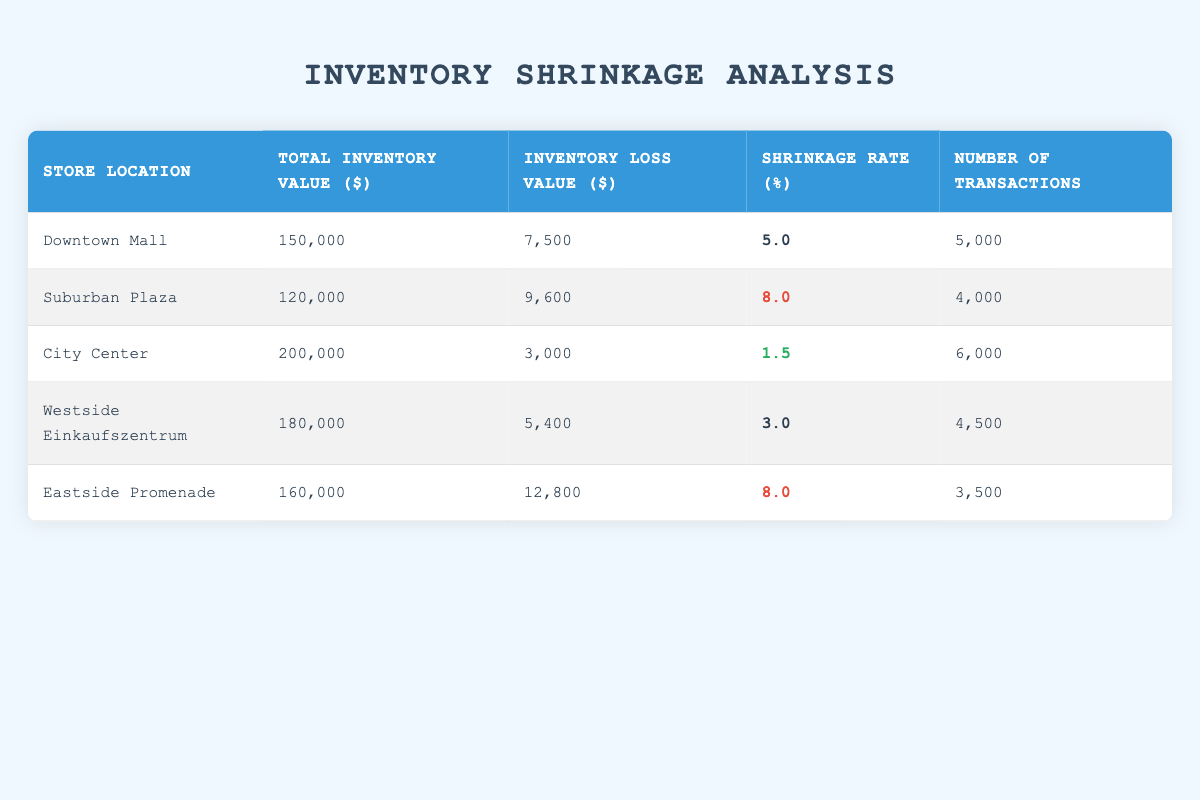What is the shrinkage rate for Eastside Promenade? The table lists the shrinkage rate for Eastside Promenade in the column under "Shrinkage Rate (%)", which shows a value of 8.0.
Answer: 8.0 Which store location has the highest inventory loss value? By examining the "Inventory Loss Value ($)" column, Eastside Promenade shows the highest loss value at 12,800.
Answer: Eastside Promenade What is the average shrinkage rate for all listed stores? To find the average shrinkage rate, sum the rates (5.0 + 8.0 + 1.5 + 3.0 + 8.0 = 25.5) and divide by the number of stores (5). Therefore, the average is 25.5 / 5 = 5.1.
Answer: 5.1 Is the shrinkage rate for Downtown Mall higher than that of City Center? The shrinkage rate for Downtown Mall is 5.0, while for City Center it is 1.5. Since 5.0 is greater than 1.5, it confirms that Downtown Mall has a higher shrinkage rate.
Answer: Yes What is the total inventory value for all stores combined? By adding the total inventory values from each store (150,000 + 120,000 + 200,000 + 180,000 + 160,000 = 910,000), we find that the total inventory value across all stores is 910,000.
Answer: 910,000 Which store has the lowest number of transactions? In the column "Number of Transactions", Eastside Promenade has the lowest value listed at 3,500 transactions.
Answer: Eastside Promenade What is the difference in shrinkage rates between Suburban Plaza and Westside Einkaufszentrum? Suburban Plaza has a shrinkage rate of 8.0, and Westside Einkaufszentrum has a rate of 3.0. The difference is 8.0 - 3.0 = 5.0.
Answer: 5.0 True or False: City Center has a higher inventory loss value than Downtown Mall. City Center has an inventory loss value of 3,000, while Downtown Mall's inventory loss is 7,500. Since 3,000 is less than 7,500, the statement is false.
Answer: False What is the total inventory loss value for all stores? To get the total inventory loss, we sum the values: (7,500 + 9,600 + 3,000 + 5,400 + 12,800 = 38,300). Thus, the total inventory loss value for all stores is 38,300.
Answer: 38,300 